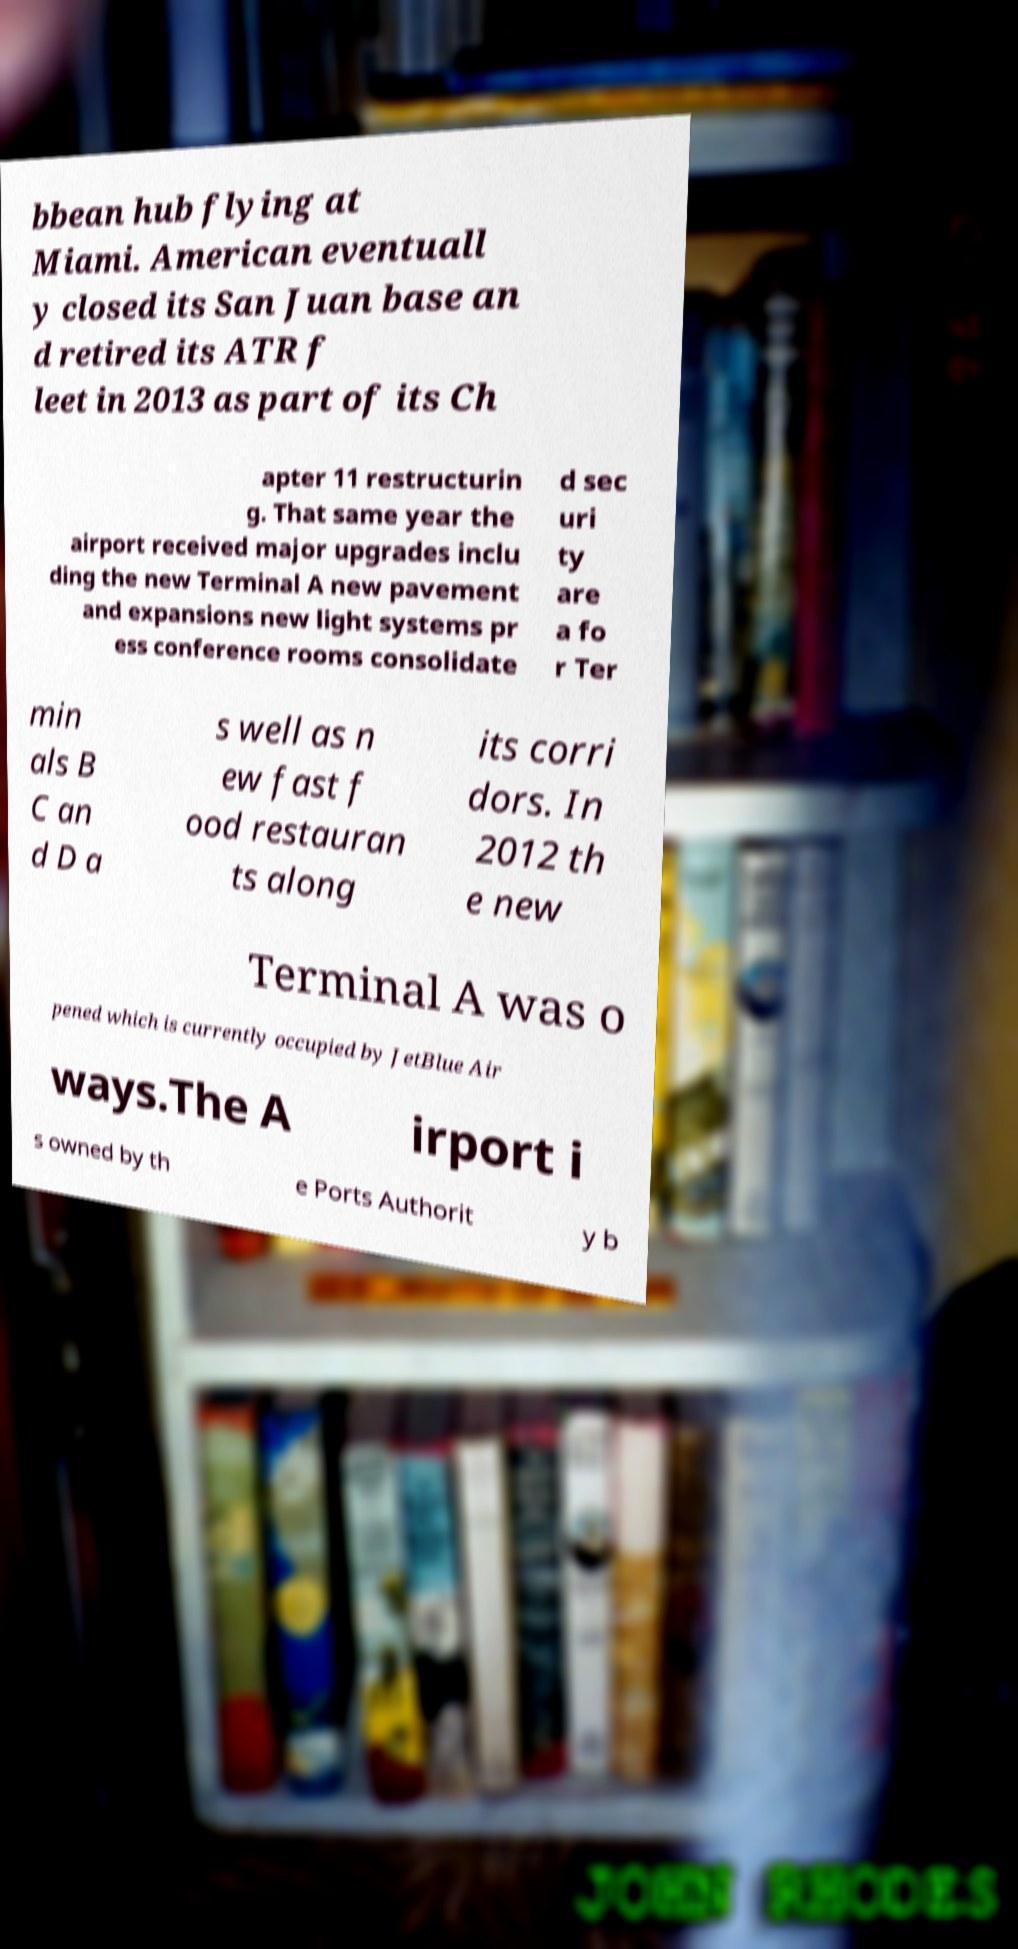What messages or text are displayed in this image? I need them in a readable, typed format. bbean hub flying at Miami. American eventuall y closed its San Juan base an d retired its ATR f leet in 2013 as part of its Ch apter 11 restructurin g. That same year the airport received major upgrades inclu ding the new Terminal A new pavement and expansions new light systems pr ess conference rooms consolidate d sec uri ty are a fo r Ter min als B C an d D a s well as n ew fast f ood restauran ts along its corri dors. In 2012 th e new Terminal A was o pened which is currently occupied by JetBlue Air ways.The A irport i s owned by th e Ports Authorit y b 